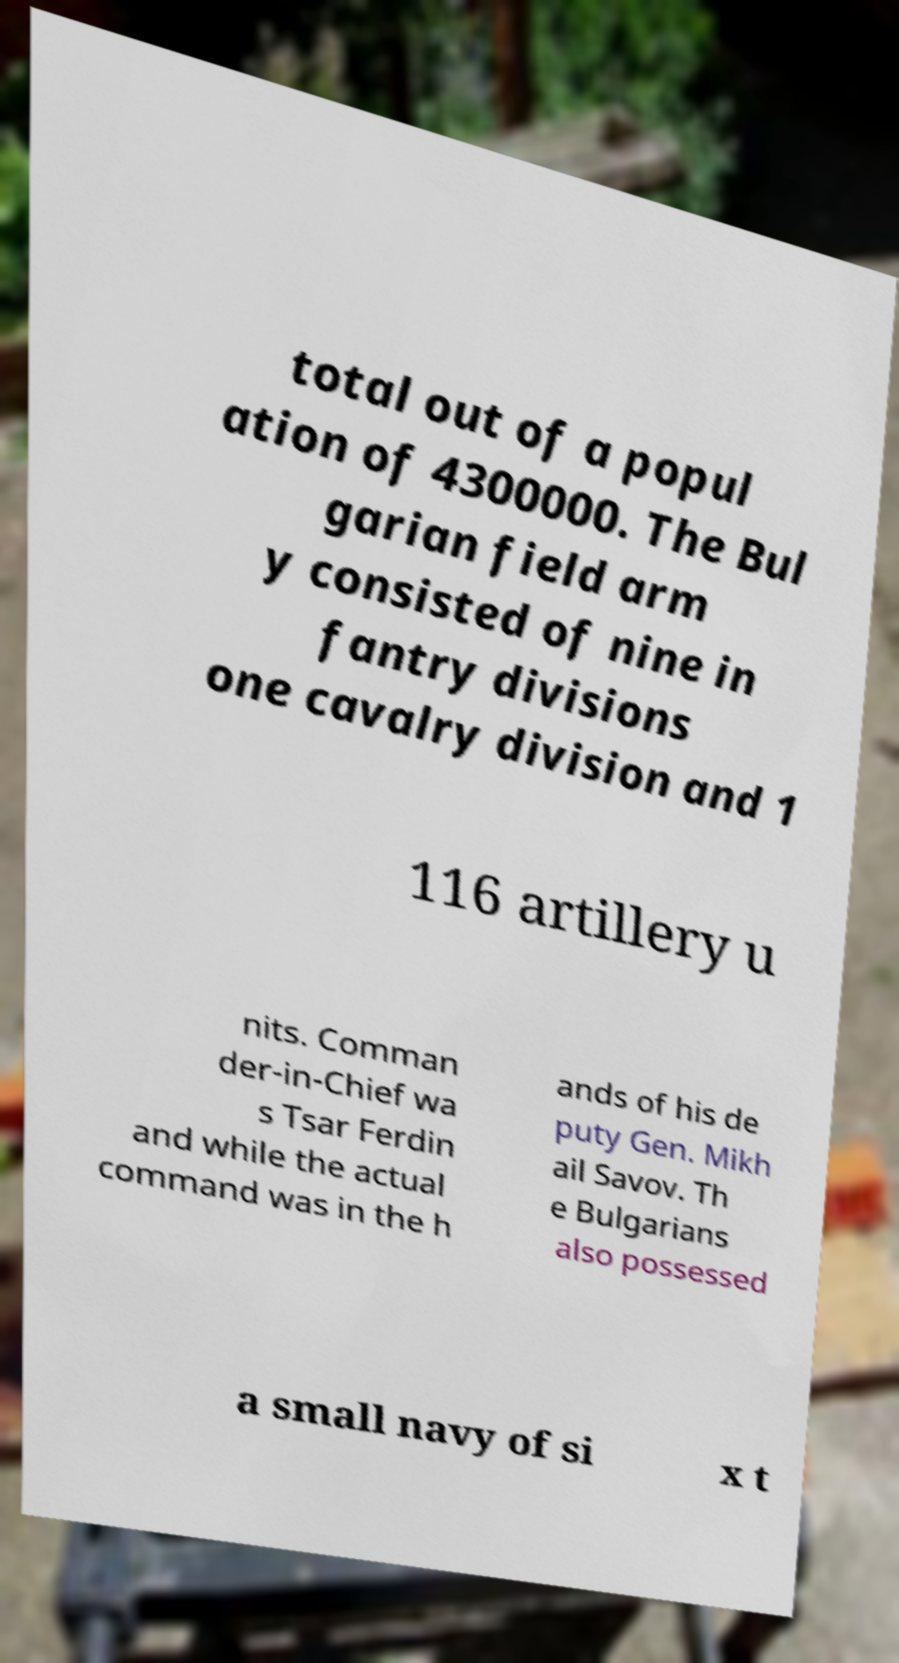Can you accurately transcribe the text from the provided image for me? total out of a popul ation of 4300000. The Bul garian field arm y consisted of nine in fantry divisions one cavalry division and 1 116 artillery u nits. Comman der-in-Chief wa s Tsar Ferdin and while the actual command was in the h ands of his de puty Gen. Mikh ail Savov. Th e Bulgarians also possessed a small navy of si x t 